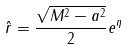<formula> <loc_0><loc_0><loc_500><loc_500>\hat { r } = \frac { \sqrt { M ^ { 2 } - a ^ { 2 } } } { 2 } e ^ { \eta }</formula> 